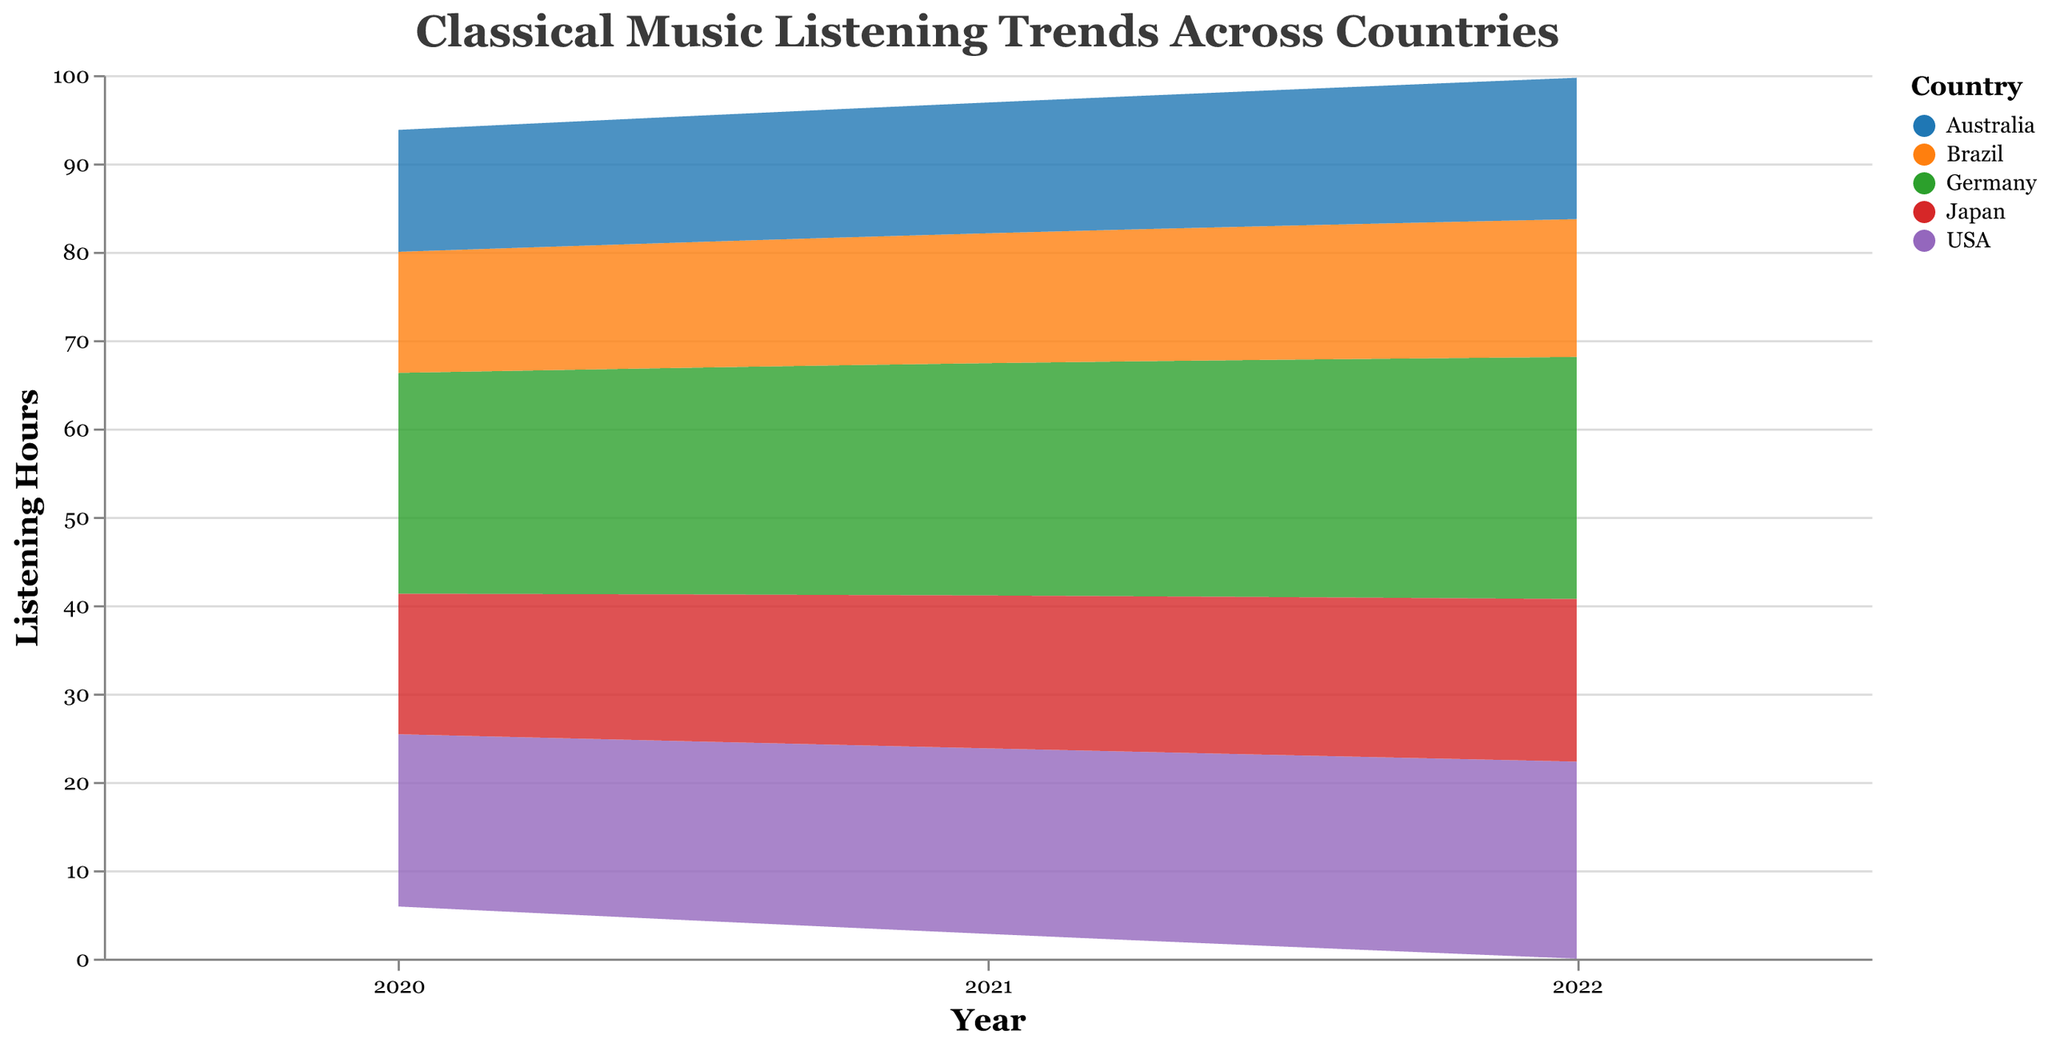What is the title of the figure? The title of the figure is typically found at the top and provides a summary of what the visualization is about. In this figure, it is "Classical Music Listening Trends Across Countries".
Answer: Classical Music Listening Trends Across Countries How many countries are represented in the figure? The color legend on the right side of the figure lists all the countries included in the plot. Each country is represented by a different color. By examining the legend, we see that there are six countries shown: USA, Germany, Japan, Brazil, Australia, and another not explicitly mentioned, but the data provides insight that it should be five based on given information.
Answer: 5 Which country had the highest listening hours for the Classical genre in 2022? To find this information, look for the segment representing '2022' and identify the color-coded section for the country with the highest bar for the Classical genre. According to the data, Germany has the highest listening hours in this genre and year.
Answer: Germany Did the USA’s listening hours for the Romantic genre increase or decrease each year from 2020 to 2022? To determine this, follow the stream for the Romantic genre over the years 2020, 2021, and 2022. By examining the plot, we see that the listening hours increased from 5.2 in 2020 to 6.0 in 2021, and then to 6.5 in 2022.
Answer: Increased Which region shows the highest overall listening trend for Classical music across all the years? To determine this, add up the listening hours for Classical music across all years for each region and identify the region with the highest total. From the visualization, Europe (Germany) shows consistently high listening hours for Classical music over the years, indicating the highest trend.
Answer: Europe Comparing Classical music listening hours between Japan and Brazil in 2021, which country had higher hours? Refer to the color-coded regions for Japan and Brazil in the year 2021, focusing on the Classical genre. From the plot, one can observe that Japan (6.9 hours) had higher listening hours than Brazil (5.9 hours).
Answer: Japan Which genre exhibits the least change in listening hours in Australia from 2020 to 2022? By tracking the respective color for each genre in Australia across 2020, 2021, and 2022, it is evident that the Romantic genre shows the least change in listening hours over these years (4.0, 4.4, and 4.7 hours respectively).
Answer: Romantic What is the difference in total listening hours for all genres combined between Germany and Japan in 2022? Sum the listening hours for all genres for both Germany and Japan in 2022. Germany has 8.9 (Baroque) + 10.1 (Classical) + 8.4 (Romantic) = 27.4 hours. Japan has 5.5 (Baroque) + 7.2 (Classical) + 5.7 (Romantic) = 18.4 hours. The difference is 27.4 - 18.4 = 9 hours.
Answer: 9 hours In which year did Brazil have the lowest total listening hours for Classical music? Examine the total listening hours for the Classical genre in Brazil across the years 2020, 2021, and 2022. Brazil’s listening hours for Classical music were 5.6 in 2020, 5.9 in 2021, and 6.2 in 2022, making 2020 the year with the lowest total listening hours for Classical music.
Answer: 2020 